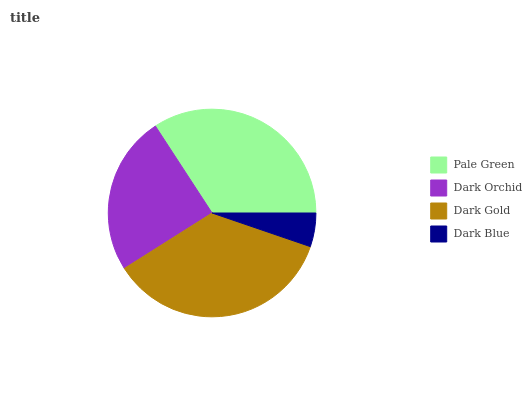Is Dark Blue the minimum?
Answer yes or no. Yes. Is Dark Gold the maximum?
Answer yes or no. Yes. Is Dark Orchid the minimum?
Answer yes or no. No. Is Dark Orchid the maximum?
Answer yes or no. No. Is Pale Green greater than Dark Orchid?
Answer yes or no. Yes. Is Dark Orchid less than Pale Green?
Answer yes or no. Yes. Is Dark Orchid greater than Pale Green?
Answer yes or no. No. Is Pale Green less than Dark Orchid?
Answer yes or no. No. Is Pale Green the high median?
Answer yes or no. Yes. Is Dark Orchid the low median?
Answer yes or no. Yes. Is Dark Blue the high median?
Answer yes or no. No. Is Dark Blue the low median?
Answer yes or no. No. 